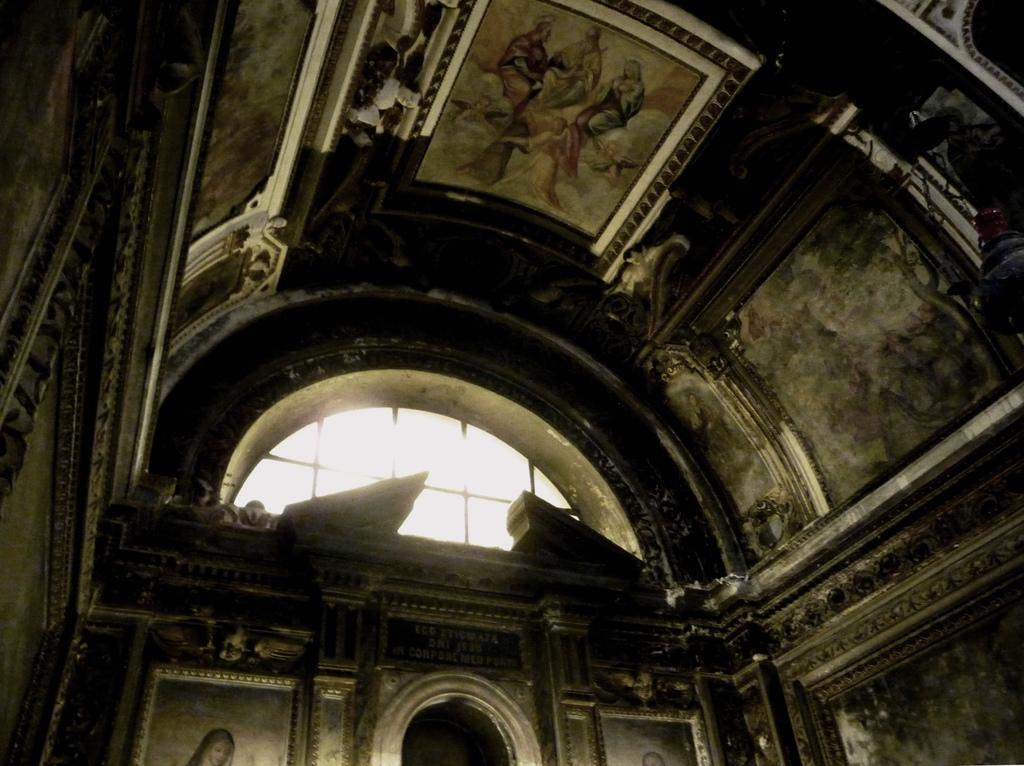Could you give a brief overview of what you see in this image? In this image we can see an inner view of a building where the walls and ceiling are having different kind of pictures. Here we can see the glass ventilators. 